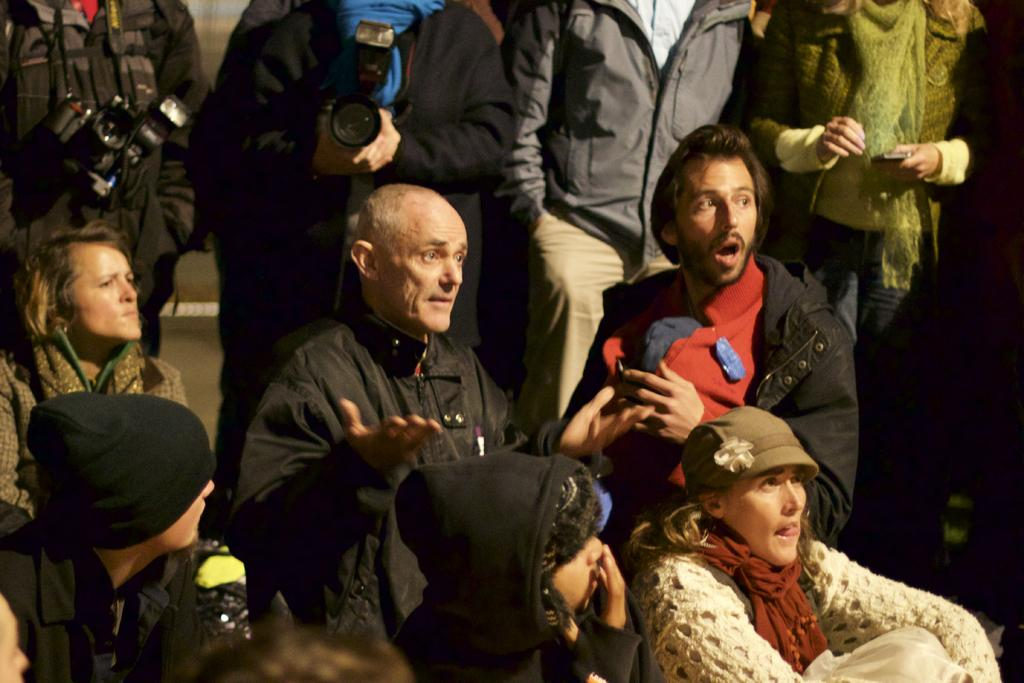What is happening in the foreground of the image? There are persons sitting and standing in the foreground of the image. What can be seen in the background of the image? In the background, there are four persons standing. Can you describe the actions or objects related to the persons in the background? Two of the persons in the background are wearing and holding cameras. What type of glue is being used by the persons in the image? There is no glue present in the image; the persons are either sitting, standing, or holding cameras. How many mailboxes are visible in the image? There are no mailboxes visible in the image. 